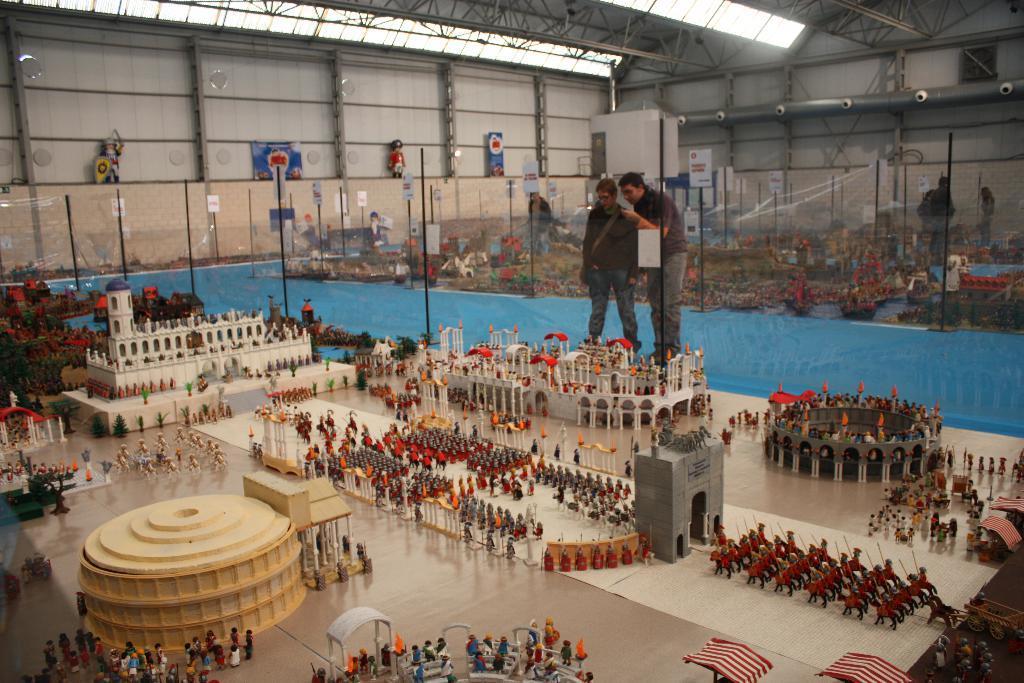In one or two sentences, can you explain what this image depicts? At the bottom of this image, there are toy persons, modal buildings, toy person's, a model gate, a modal tent, modal trees and other objects arranged on a floor. In the background, there are other persons, other toys, model buildings, poles and boards arranged. 